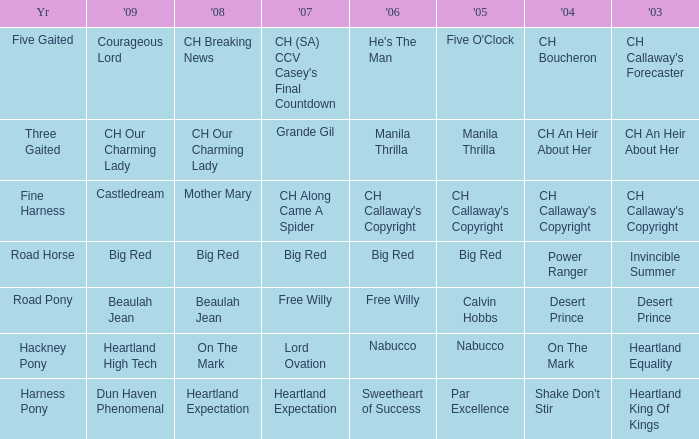What year is the 2007 big red? Road Horse. 